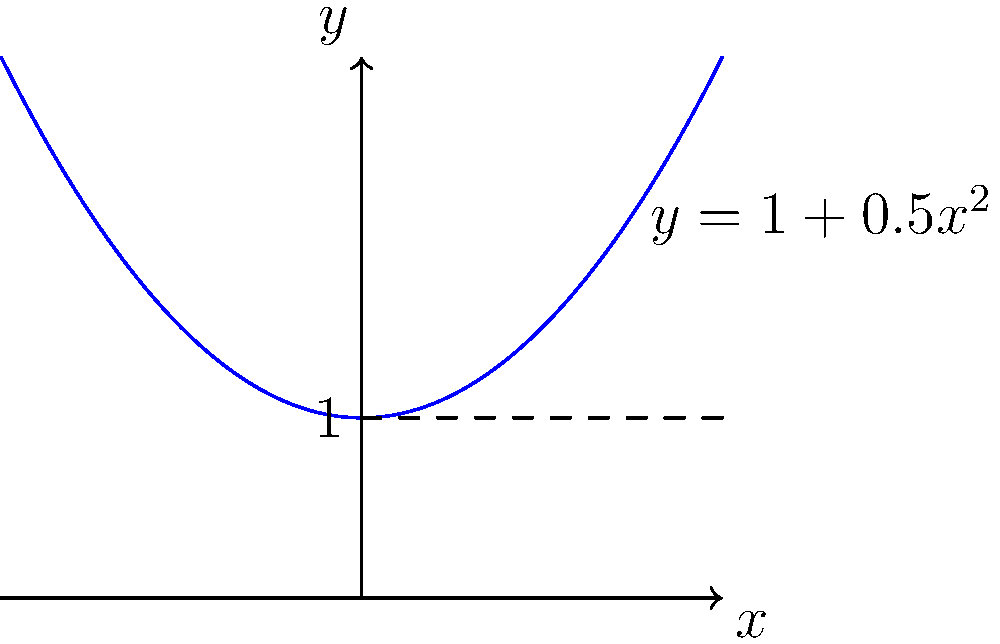As a self-taught rocket scientist, you're designing a cylindrical fuel tank for your latest rocket. The tank's radius varies along its length according to the function $r(x) = \sqrt{1+0.5x^2}$, where $x$ is the distance along the tank's axis in meters, and $r$ is the radius in meters. If the tank extends from $x=-2$ to $x=2$, calculate its volume using integration. To solve this problem, we'll follow these steps:

1) The volume of a solid of revolution is given by the formula:
   $$V = \pi \int_{a}^{b} [r(x)]^2 dx$$

2) In this case, $r(x) = \sqrt{1+0.5x^2}$, $a=-2$, and $b=2$

3) Substituting these into our formula:
   $$V = \pi \int_{-2}^{2} (1+0.5x^2) dx$$

4) Expanding the integrand:
   $$V = \pi \int_{-2}^{2} (1+0.5x^2) dx$$

5) Integrating:
   $$V = \pi [x + \frac{1}{6}x^3]_{-2}^{2}$$

6) Evaluating the definite integral:
   $$V = \pi [(2 + \frac{1}{6}(2^3)) - (-2 + \frac{1}{6}(-2^3))]$$
   $$V = \pi [(2 + \frac{4}{3}) - (-2 - \frac{4}{3})]$$
   $$V = \pi [(\frac{10}{3}) - (-\frac{10}{3})]$$
   $$V = \pi [\frac{20}{3}]$$

7) Simplifying:
   $$V = \frac{20\pi}{3} \approx 20.94 \text{ cubic meters}$$
Answer: $\frac{20\pi}{3}$ cubic meters 